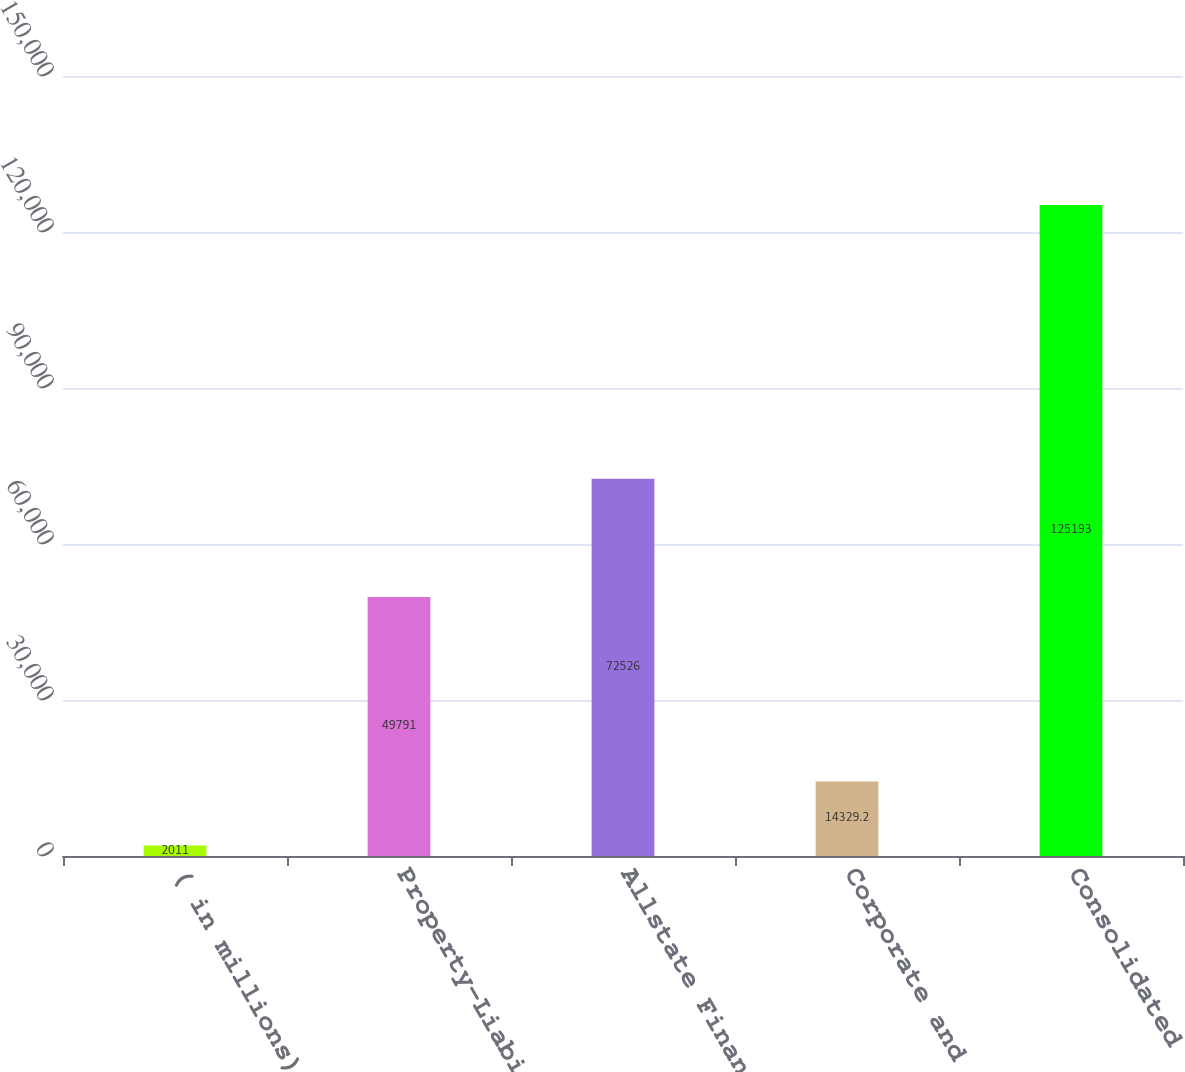<chart> <loc_0><loc_0><loc_500><loc_500><bar_chart><fcel>( in millions)<fcel>Property-Liability<fcel>Allstate Financial<fcel>Corporate and Other<fcel>Consolidated<nl><fcel>2011<fcel>49791<fcel>72526<fcel>14329.2<fcel>125193<nl></chart> 